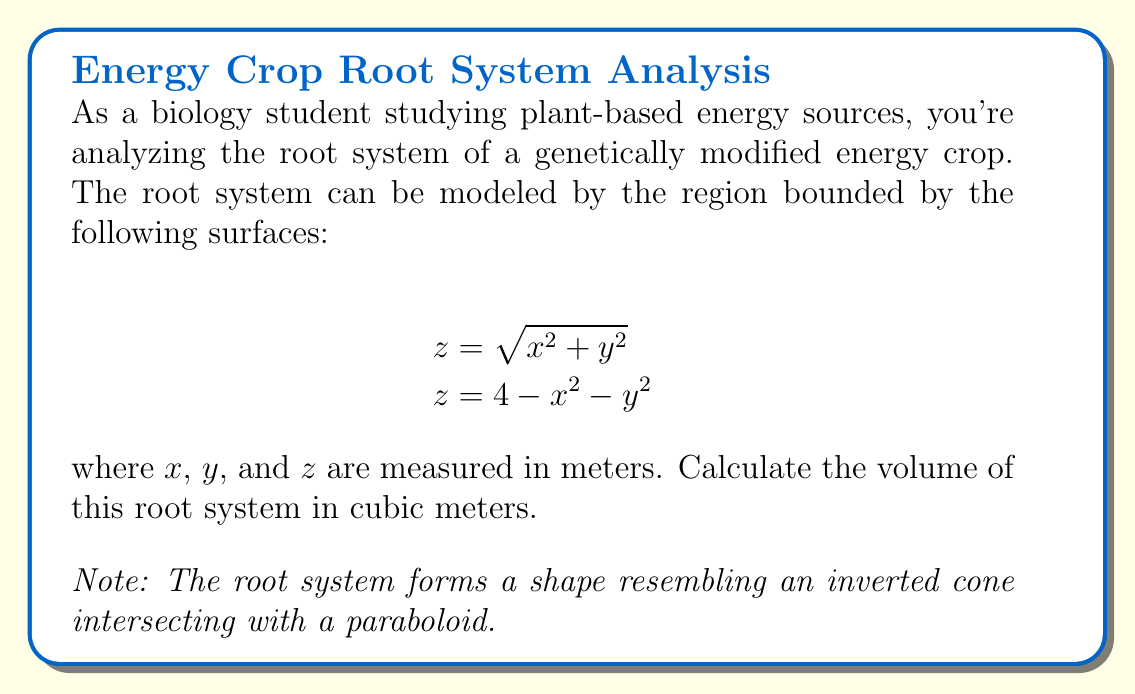Help me with this question. To solve this problem, we'll use triple integration in cylindrical coordinates. Let's approach this step-by-step:

1) First, we need to find the intersection of the two surfaces to determine the limits of integration:

   $$\sqrt{x^2 + y^2} = 4 - x^2 - y^2$$

2) Squaring both sides:

   $$x^2 + y^2 = 16 - 8x^2 - 8y^2 + x^4 + 2x^2y^2 + y^4$$

3) Simplifying:

   $$9x^2 + 9y^2 - 16 + x^4 + 2x^2y^2 + y^4 = 0$$

4) This is the equation of a circle in the xy-plane. To find its radius, let $x^2 + y^2 = r^2$:

   $$9r^2 - 16 + r^4 = 0$$
   $$r^4 + 9r^2 - 16 = 0$$

5) Solving this quadratic in $r^2$:

   $$r^2 = \frac{-9 + \sqrt{81 + 64}}{2} = \frac{-9 + \sqrt{145}}{2} \approx 1.5$$

6) Now we can set up the triple integral in cylindrical coordinates:

   $$V = \int_0^{2\pi} \int_0^{\sqrt{1.5}} \int_{\sqrt{r^2}}^{4-r^2} r \, dz \, dr \, d\theta$$

7) Evaluating the innermost integral:

   $$V = \int_0^{2\pi} \int_0^{\sqrt{1.5}} r(4-r^2 - \sqrt{r^2}) \, dr \, d\theta$$

8) Integrating with respect to $r$:

   $$V = \int_0^{2\pi} \left[\frac{4r^2}{2} - \frac{r^4}{4} - \frac{2r^2}{3}\right]_0^{\sqrt{1.5}} \, d\theta$$

9) Evaluating at the limits:

   $$V = \int_0^{2\pi} \left(3 - \frac{9}{16} - \sqrt{1.5}\right) \, d\theta$$

10) Finally, integrating with respect to $\theta$:

    $$V = 2\pi \left(3 - \frac{9}{16} - \sqrt{1.5}\right) \approx 8.389$$

Thus, the volume of the root system is approximately 8.389 cubic meters.
Answer: $2\pi(3 - \frac{9}{16} - \sqrt{1.5}) \approx 8.389$ cubic meters 